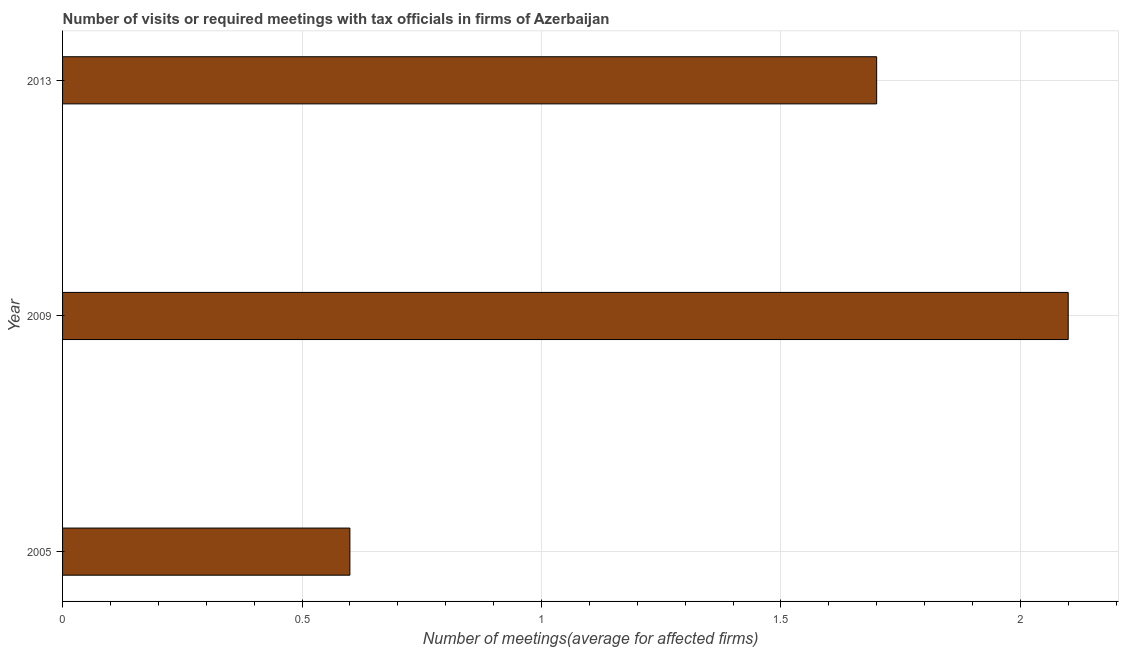Does the graph contain any zero values?
Offer a very short reply. No. What is the title of the graph?
Your answer should be compact. Number of visits or required meetings with tax officials in firms of Azerbaijan. What is the label or title of the X-axis?
Offer a very short reply. Number of meetings(average for affected firms). What is the label or title of the Y-axis?
Provide a short and direct response. Year. In which year was the number of required meetings with tax officials maximum?
Offer a terse response. 2009. In which year was the number of required meetings with tax officials minimum?
Make the answer very short. 2005. What is the average number of required meetings with tax officials per year?
Your response must be concise. 1.47. Do a majority of the years between 2009 and 2005 (inclusive) have number of required meetings with tax officials greater than 0.7 ?
Ensure brevity in your answer.  No. What is the ratio of the number of required meetings with tax officials in 2005 to that in 2013?
Your answer should be very brief. 0.35. Is the difference between the number of required meetings with tax officials in 2005 and 2009 greater than the difference between any two years?
Provide a succinct answer. Yes. What is the difference between the highest and the lowest number of required meetings with tax officials?
Your response must be concise. 1.5. In how many years, is the number of required meetings with tax officials greater than the average number of required meetings with tax officials taken over all years?
Provide a short and direct response. 2. How many bars are there?
Ensure brevity in your answer.  3. How many years are there in the graph?
Make the answer very short. 3. Are the values on the major ticks of X-axis written in scientific E-notation?
Your response must be concise. No. What is the Number of meetings(average for affected firms) in 2005?
Your answer should be compact. 0.6. What is the Number of meetings(average for affected firms) of 2013?
Your answer should be compact. 1.7. What is the difference between the Number of meetings(average for affected firms) in 2005 and 2009?
Provide a succinct answer. -1.5. What is the difference between the Number of meetings(average for affected firms) in 2005 and 2013?
Keep it short and to the point. -1.1. What is the difference between the Number of meetings(average for affected firms) in 2009 and 2013?
Make the answer very short. 0.4. What is the ratio of the Number of meetings(average for affected firms) in 2005 to that in 2009?
Give a very brief answer. 0.29. What is the ratio of the Number of meetings(average for affected firms) in 2005 to that in 2013?
Your answer should be compact. 0.35. What is the ratio of the Number of meetings(average for affected firms) in 2009 to that in 2013?
Provide a short and direct response. 1.24. 